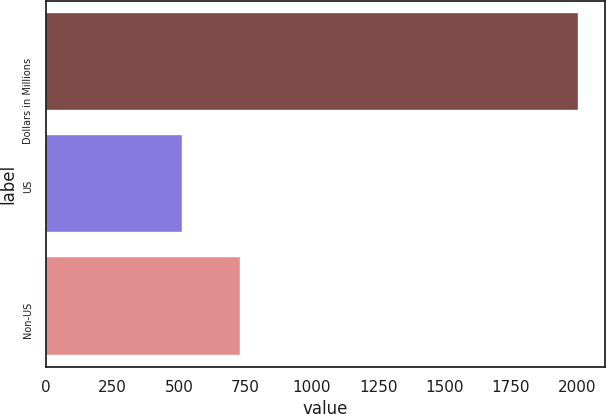<chart> <loc_0><loc_0><loc_500><loc_500><bar_chart><fcel>Dollars in Millions<fcel>US<fcel>Non-US<nl><fcel>2004<fcel>513<fcel>728<nl></chart> 